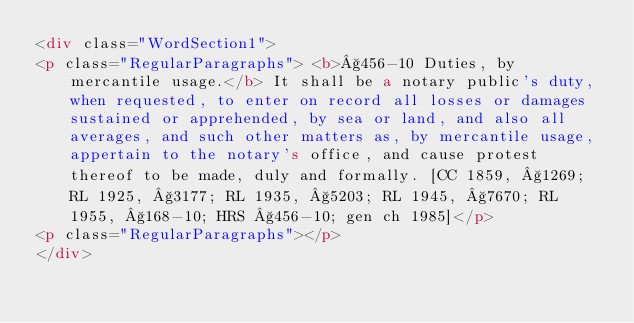Convert code to text. <code><loc_0><loc_0><loc_500><loc_500><_HTML_><div class="WordSection1">
<p class="RegularParagraphs"> <b>§456-10 Duties, by mercantile usage.</b> It shall be a notary public's duty, when requested, to enter on record all losses or damages sustained or apprehended, by sea or land, and also all averages, and such other matters as, by mercantile usage, appertain to the notary's office, and cause protest thereof to be made, duly and formally. [CC 1859, §1269; RL 1925, §3177; RL 1935, §5203; RL 1945, §7670; RL 1955, §168-10; HRS §456-10; gen ch 1985]</p>
<p class="RegularParagraphs"></p>
</div></code> 